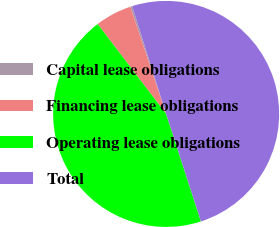Convert chart. <chart><loc_0><loc_0><loc_500><loc_500><pie_chart><fcel>Capital lease obligations<fcel>Financing lease obligations<fcel>Operating lease obligations<fcel>Total<nl><fcel>0.27%<fcel>5.23%<fcel>44.62%<fcel>49.88%<nl></chart> 